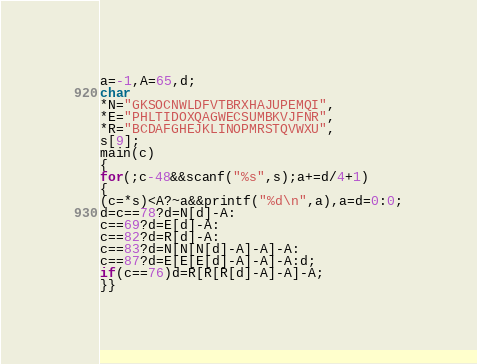<code> <loc_0><loc_0><loc_500><loc_500><_C_>a=-1,A=65,d;
char
*N="GKSOCNWLDFVTBRXHAJUPEMQI",
*E="PHLTIDOXQAGWECSUMBKVJFNR",
*R="BCDAFGHEJKLINOPMRSTQVWXU",
s[9];
main(c)
{
for(;c-48&&scanf("%s",s);a+=d/4+1)
{
(c=*s)<A?~a&&printf("%d\n",a),a=d=0:0;
d=c==78?d=N[d]-A:
c==69?d=E[d]-A:
c==82?d=R[d]-A:
c==83?d=N[N[N[d]-A]-A]-A:
c==87?d=E[E[E[d]-A]-A]-A:d;
if(c==76)d=R[R[R[d]-A]-A]-A;
}}</code> 